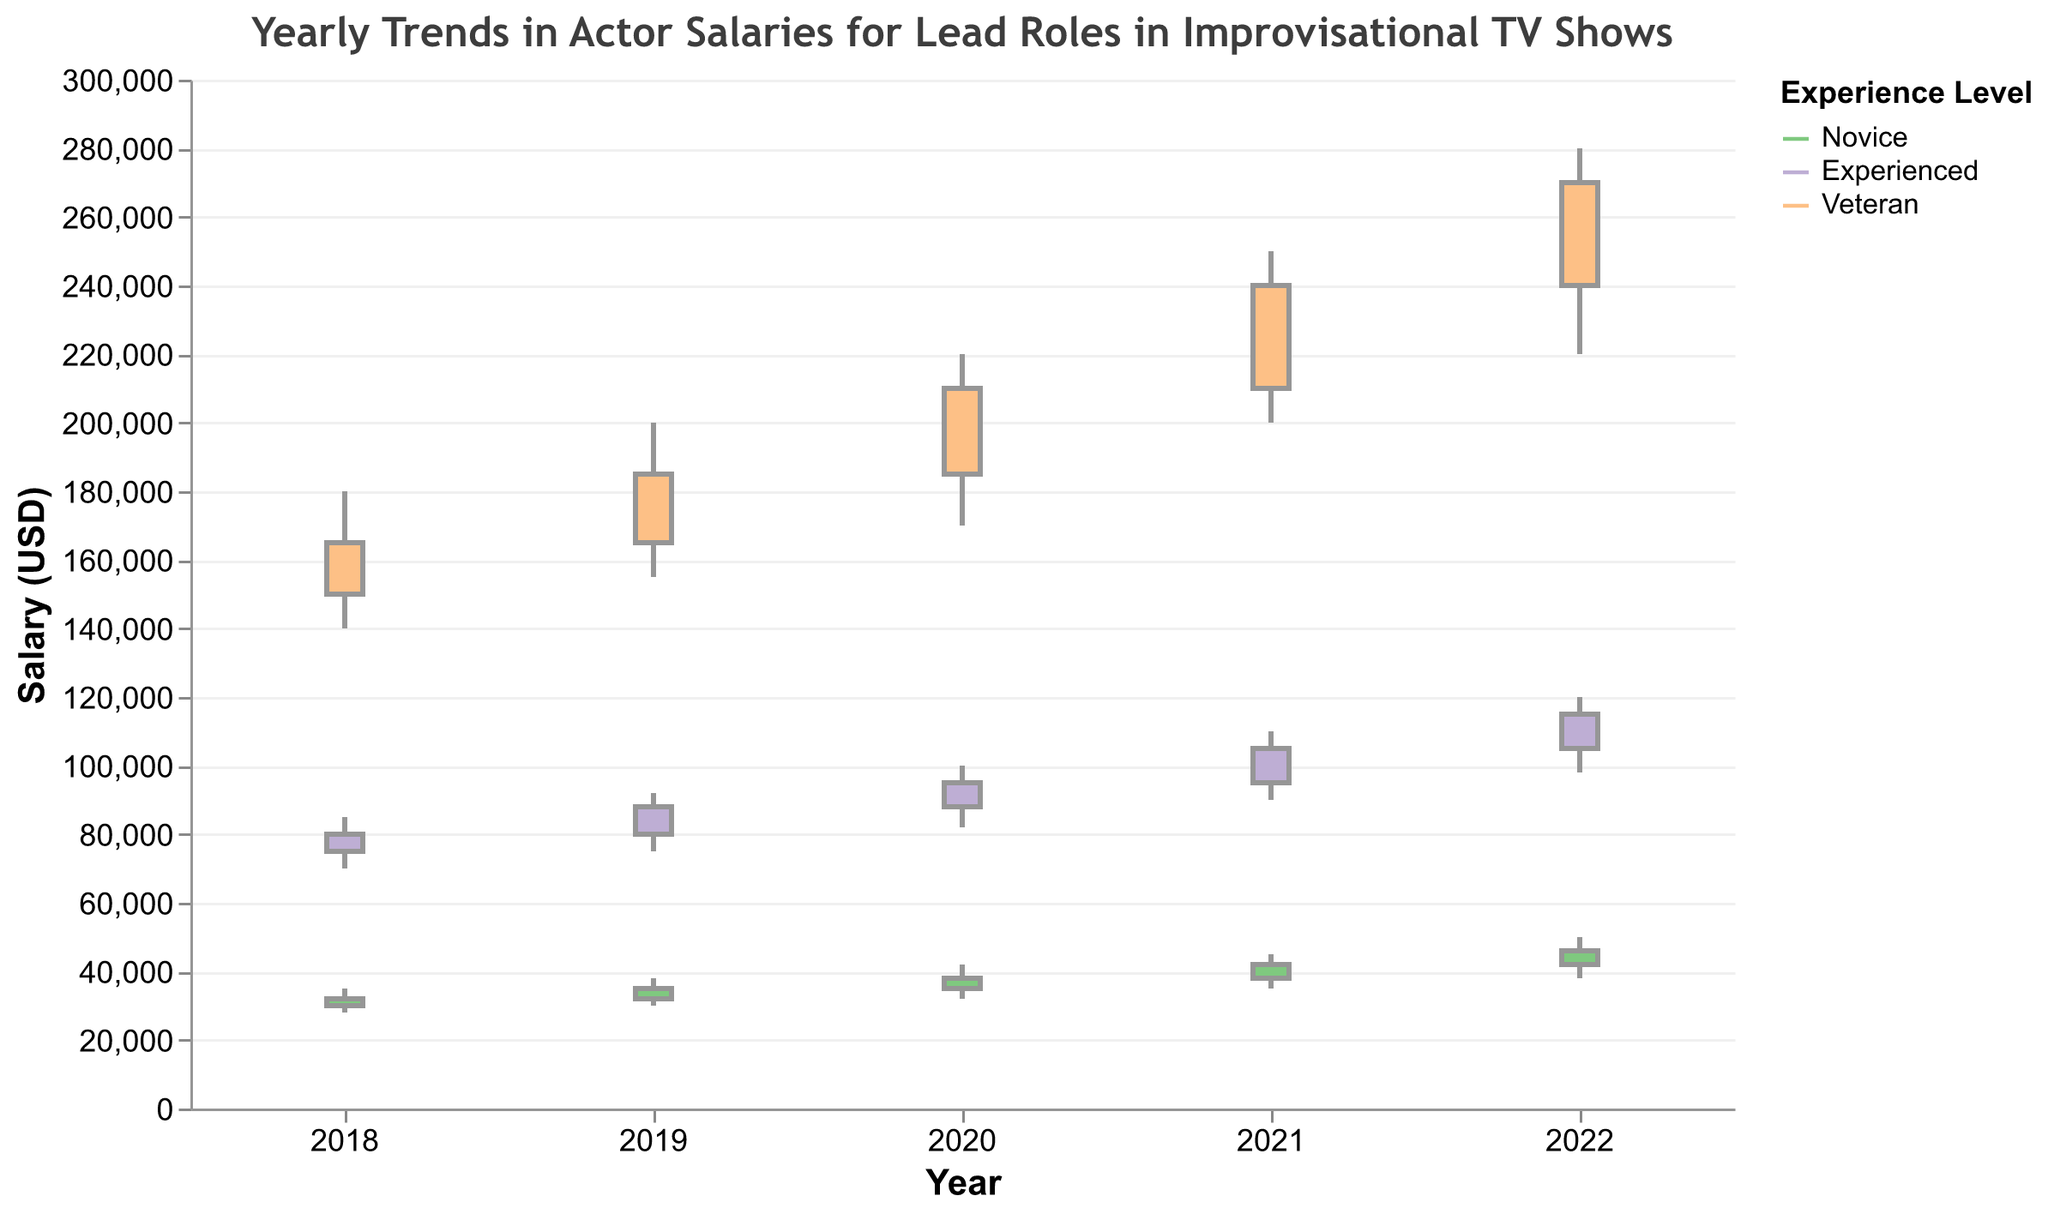What is the title of the chart? The title can be found at the top of the chart. It provides an overview of what the chart represents.
Answer: Yearly Trends in Actor Salaries for Lead Roles in Improvisational TV Shows Which experience level had the highest salary in 2022? By looking at the highest value on the y-axis for each experience level in 2022, we can determine that 'Veteran' actors had the highest salary.
Answer: Veteran What is the range of salaries for Novice actors in 2020? The range is calculated by subtracting the lowest salary (Low) from the highest salary (High) for Novice actors in 2020. High is 42000, Low is 32000, so the range is 42000 - 32000 = 10000.
Answer: 10000 Did Experienced actors' salaries always increase year-over-year from 2018 to 2022? We need to track the closing salary values for Experienced actors across the years. We see 80000 (2018), 88000 (2019), 95000 (2020), 105000 (2021), 115000 (2022). Since each value is higher than the previous year's, the salaries always increased.
Answer: Yes Which year saw the highest increase in the closing salaries for Veteran actors? We need to calculate the difference in closing salaries for Veterans year-over-year and identify the largest increase. Differences are:
165000 to 185000 = 20000 (2018 to 2019),
185000 to 210000 = 25000 (2019 to 2020),
210000 to 240000 = 30000 (2020 to 2021),
240000 to 270000 = 30000 (2021 to 2022). Highest increases are in 2020-2021 and 2021-2022, both are same at 30000.
Answer: 2020-2021 and 2021-2022 Are there any years where the closing salary of Novice actors decreased compared to the previous year? We need to compare the closing salaries of Novice actors year-over-year:
32000 (2018), 35000 (2019), 38000 (2020), 42000 (2021), 46000 (2022). Each year, the closing salary has increased.
Answer: No What was the lowest salary for Experienced actors in 2018? The lowest salary value can be directly observed from the Low value for Experienced actors in 2018, which is 70000.
Answer: 70000 How much did the closing salary for Veterans increase from 2018 to 2022? The closing salary for Veterans in 2018 was 165000 and in 2022 was 270000. So, the increase is 270000 - 165000 = 105000.
Answer: 105000 Which experience level has the smallest salary range in 2022? We need to compare the salary ranges (High - Low) for each experience level in 2022:
Novice: 50000 - 38000 = 12000,
Experienced: 120000 - 98000 = 22000,
Veteran: 280000 - 220000 = 60000.
The smallest range is for Novice, at 12000.
Answer: Novice How does the trend for Novice actors' salaries compare to Experienced actors' salaries from 2018 to 2022? By comparing the closing salaries year-by-year for both Novice and Experienced actors:
Novice: 32000, 35000, 38000, 42000, 46000.
Experienced: 80000, 88000, 95000, 105000, 115000.
Both groups show a consistent increase over the years.
Answer: Both show a consistent increase 